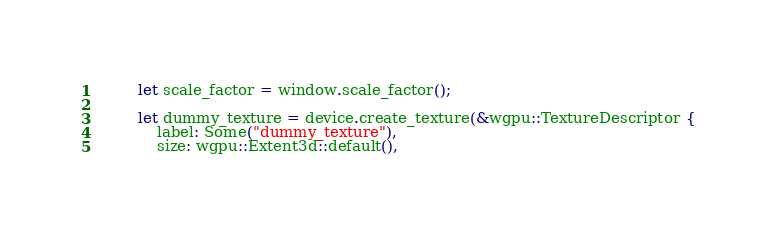<code> <loc_0><loc_0><loc_500><loc_500><_Rust_>        let scale_factor = window.scale_factor();

        let dummy_texture = device.create_texture(&wgpu::TextureDescriptor {
            label: Some("dummy_texture"),
            size: wgpu::Extent3d::default(),</code> 